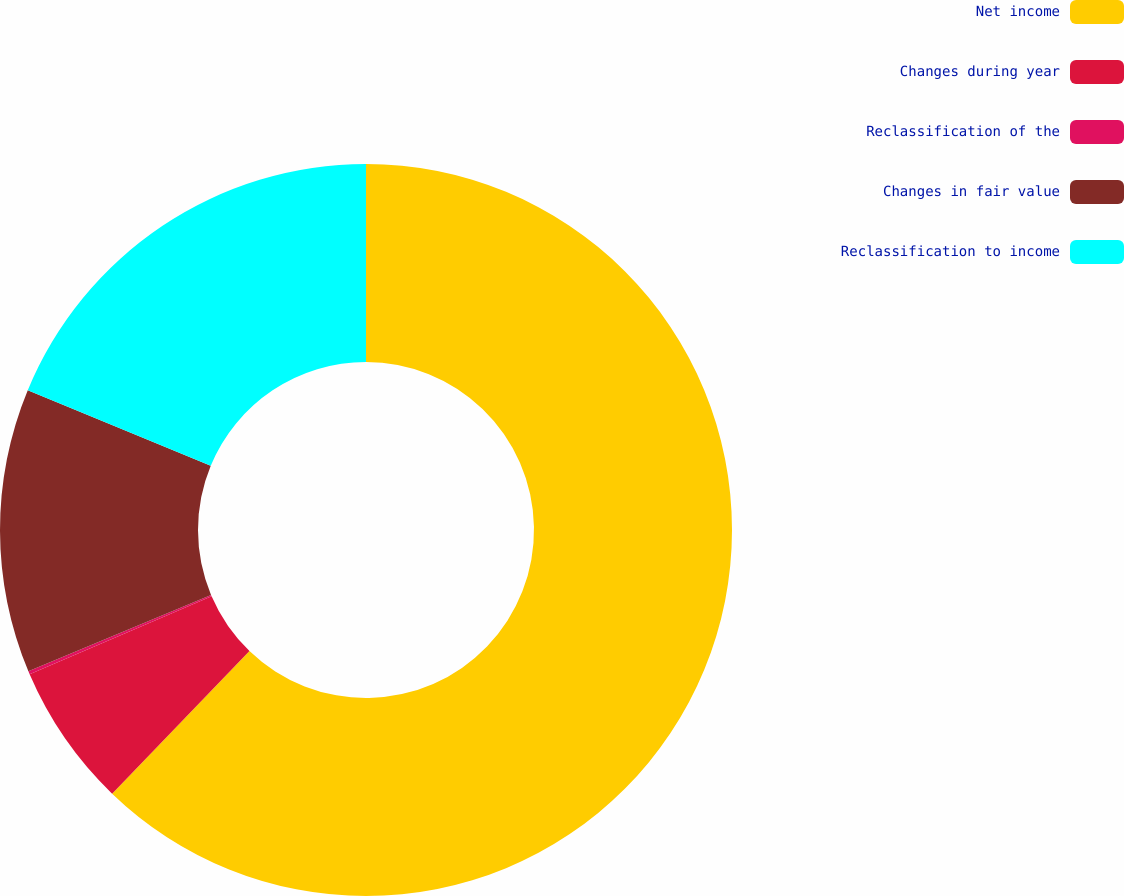<chart> <loc_0><loc_0><loc_500><loc_500><pie_chart><fcel>Net income<fcel>Changes during year<fcel>Reclassification of the<fcel>Changes in fair value<fcel>Reclassification to income<nl><fcel>62.2%<fcel>6.35%<fcel>0.14%<fcel>12.55%<fcel>18.76%<nl></chart> 